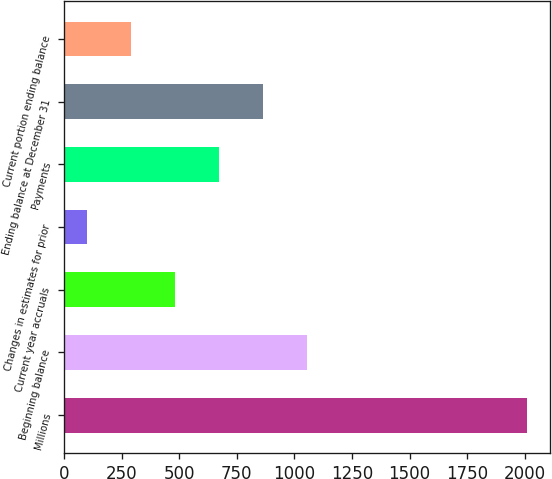<chart> <loc_0><loc_0><loc_500><loc_500><bar_chart><fcel>Millions<fcel>Beginning balance<fcel>Current year accruals<fcel>Changes in estimates for prior<fcel>Payments<fcel>Ending balance at December 31<fcel>Current portion ending balance<nl><fcel>2010<fcel>1055.5<fcel>482.8<fcel>101<fcel>673.7<fcel>864.6<fcel>291.9<nl></chart> 